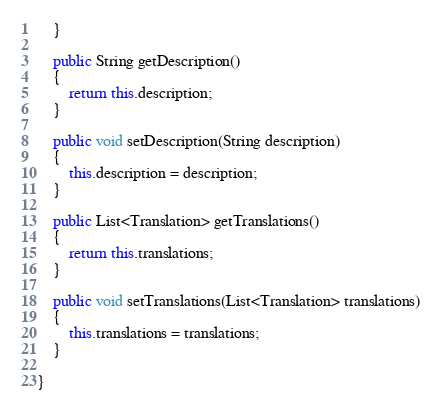Convert code to text. <code><loc_0><loc_0><loc_500><loc_500><_Java_>	}

	public String getDescription()
	{
		return this.description;
	}

	public void setDescription(String description)
	{
		this.description = description;
	}

	public List<Translation> getTranslations()
	{
		return this.translations;
	}

	public void setTranslations(List<Translation> translations)
	{
		this.translations = translations;
	}

}
</code> 